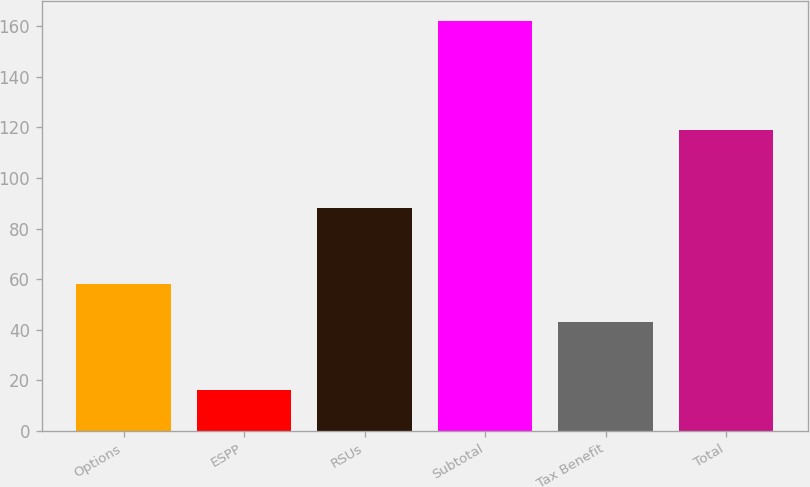<chart> <loc_0><loc_0><loc_500><loc_500><bar_chart><fcel>Options<fcel>ESPP<fcel>RSUs<fcel>Subtotal<fcel>Tax Benefit<fcel>Total<nl><fcel>58<fcel>16<fcel>88<fcel>162<fcel>43<fcel>119<nl></chart> 